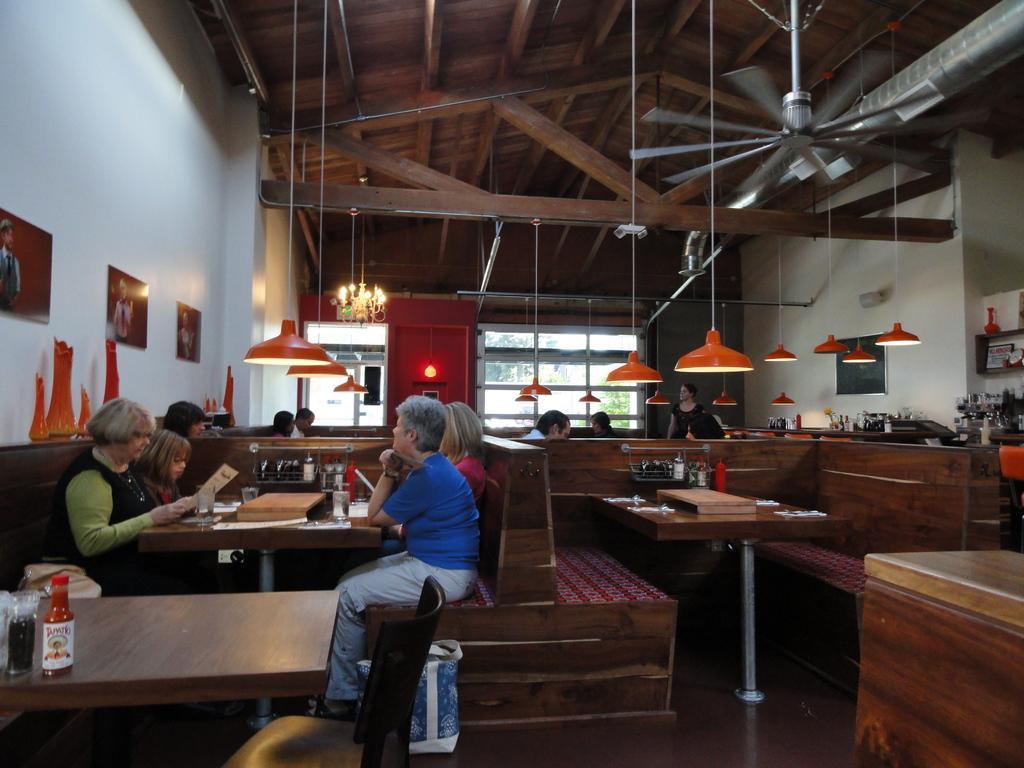Can you describe this image briefly? People are sitting at a table in a restaurant. There are four people at a table. Lights are hanging from the roof. There are photo frames on the wall. A fan is hanging from the roof. 